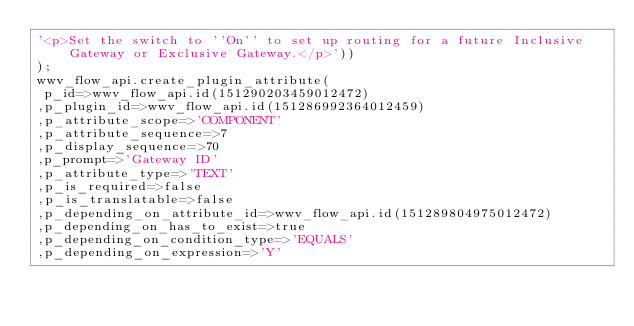Convert code to text. <code><loc_0><loc_0><loc_500><loc_500><_SQL_>'<p>Set the switch to ''On'' to set up routing for a future Inclusive Gateway or Exclusive Gateway.</p>'))
);
wwv_flow_api.create_plugin_attribute(
 p_id=>wwv_flow_api.id(151290203459012472)
,p_plugin_id=>wwv_flow_api.id(151286992364012459)
,p_attribute_scope=>'COMPONENT'
,p_attribute_sequence=>7
,p_display_sequence=>70
,p_prompt=>'Gateway ID'
,p_attribute_type=>'TEXT'
,p_is_required=>false
,p_is_translatable=>false
,p_depending_on_attribute_id=>wwv_flow_api.id(151289804975012472)
,p_depending_on_has_to_exist=>true
,p_depending_on_condition_type=>'EQUALS'
,p_depending_on_expression=>'Y'</code> 